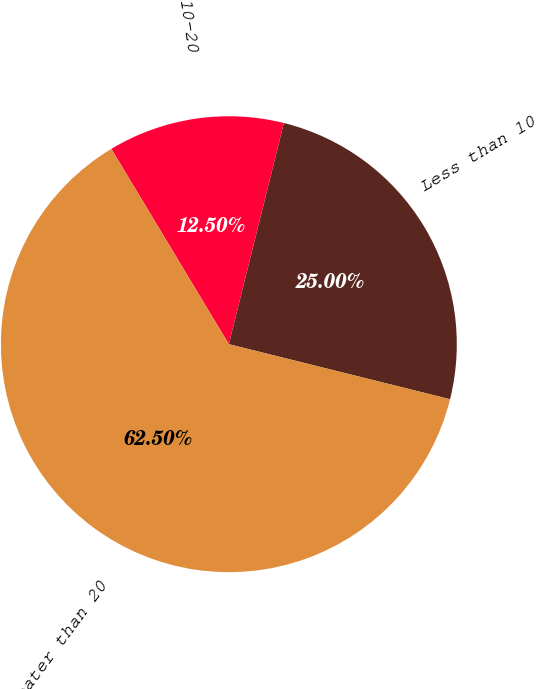Convert chart. <chart><loc_0><loc_0><loc_500><loc_500><pie_chart><fcel>Less than 10<fcel>10-20<fcel>Greater than 20<nl><fcel>25.0%<fcel>12.5%<fcel>62.5%<nl></chart> 